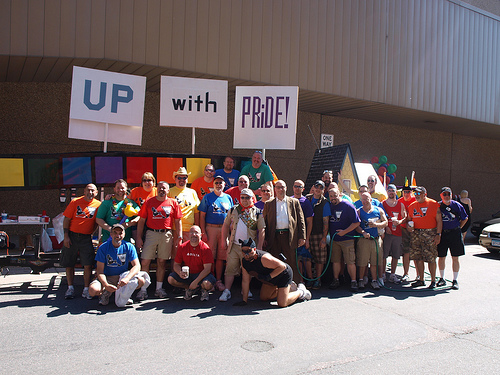<image>
Can you confirm if the man is to the left of the man? Yes. From this viewpoint, the man is positioned to the left side relative to the man. Is the car behind the man? Yes. From this viewpoint, the car is positioned behind the man, with the man partially or fully occluding the car. 